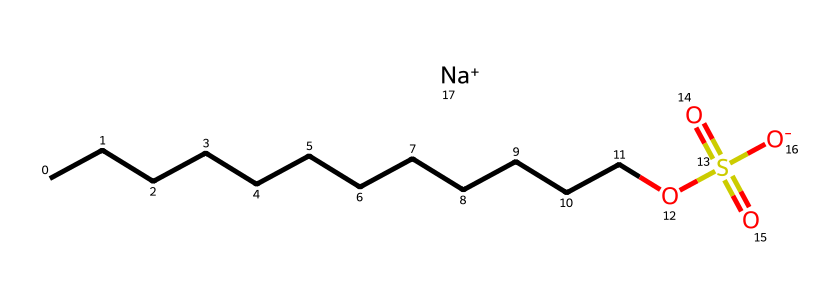How many carbon atoms are in sodium lauryl sulfate? The chemical structure shows a long hydrocarbon chain with a total of twelve carbon atoms (CCCCCCCCCCCC), as indicated by counting the 'C' elements in the chain.
Answer: twelve What functional group is present in sodium lauryl sulfate? The chemical structure contains a sulfonate group, which is represented by the portion -OS(=O)(=O)[O-]. This indicates the presence of sulfur and oxygen atoms, characteristic of sulfonates.
Answer: sulfonate How many oxygen atoms are present in sodium lauryl sulfate? In the structure, we identify three oxygen atoms in the sulfonate group as well as the one bonded to the carbon chain, totaling four oxygen atoms present in the entire molecule.
Answer: four What is the significance of sodium in sodium lauryl sulfate? Sodium serves as a counterion to balance the negative charge in the sulfonate group ([O-]), which contributes to the surfactant's properties by enhancing solubility in water.
Answer: counterion Is sodium lauryl sulfate anionic or cationic surfactant? The presence of the negatively charged sulfonate group ([O-]) indicates that sodium lauryl sulfate is anionic, meaning it carries a negative charge.
Answer: anionic What role does sodium lauryl sulfate play in baby shampoos? Sodium lauryl sulfate acts as a surfactant, lowering surface tension and helping to cleanse by removing dirt and oil from surfaces, including hair and skin.
Answer: surfactant 